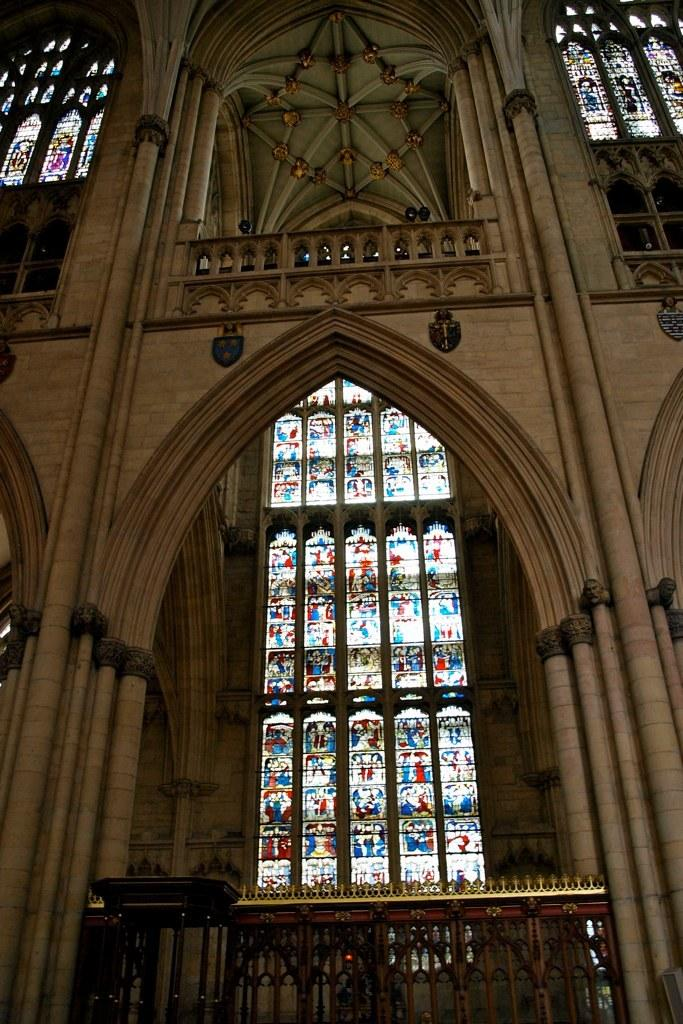What type of structure is visible in the image? There is a building in the image. What specific features can be observed on the building? The building has glass elements and designs on it. Where is the building located in relation to the image? The building is in the background of the image. What type of yarn is being used to create the designs on the building in the image? There is no yarn present in the image; the designs on the building are not made of yarn. 